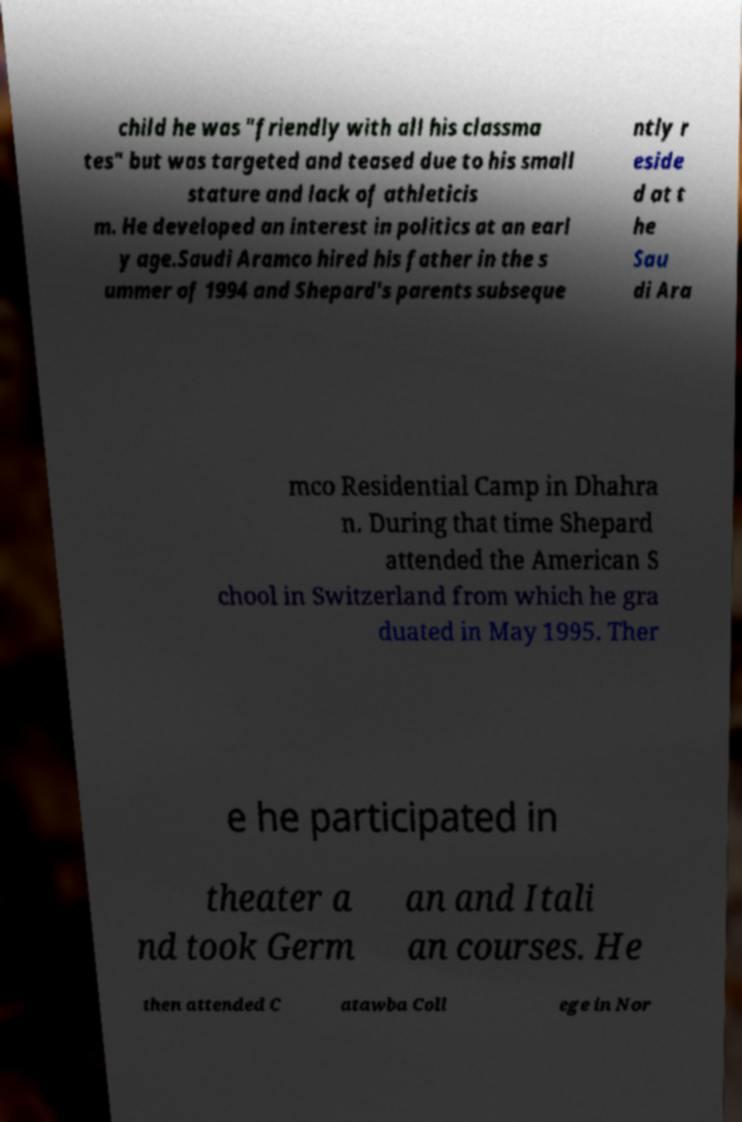I need the written content from this picture converted into text. Can you do that? child he was "friendly with all his classma tes" but was targeted and teased due to his small stature and lack of athleticis m. He developed an interest in politics at an earl y age.Saudi Aramco hired his father in the s ummer of 1994 and Shepard's parents subseque ntly r eside d at t he Sau di Ara mco Residential Camp in Dhahra n. During that time Shepard attended the American S chool in Switzerland from which he gra duated in May 1995. Ther e he participated in theater a nd took Germ an and Itali an courses. He then attended C atawba Coll ege in Nor 